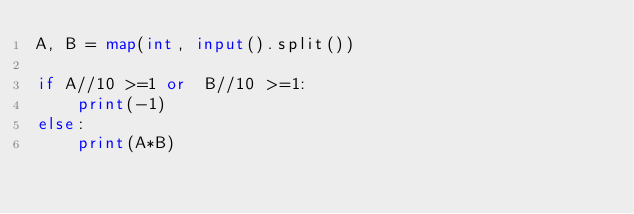<code> <loc_0><loc_0><loc_500><loc_500><_Python_>A, B = map(int, input().split())

if A//10 >=1 or  B//10 >=1:
    print(-1)
else:
    print(A*B)</code> 